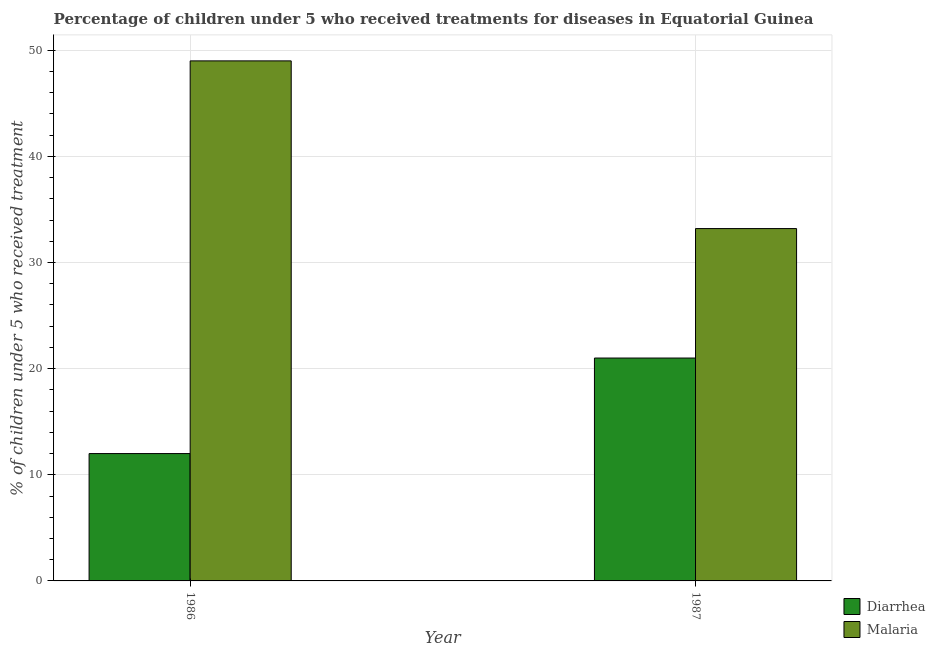How many different coloured bars are there?
Give a very brief answer. 2. How many groups of bars are there?
Ensure brevity in your answer.  2. How many bars are there on the 1st tick from the left?
Offer a terse response. 2. How many bars are there on the 1st tick from the right?
Your answer should be compact. 2. In how many cases, is the number of bars for a given year not equal to the number of legend labels?
Make the answer very short. 0. What is the percentage of children who received treatment for diarrhoea in 1986?
Your answer should be compact. 12. Across all years, what is the maximum percentage of children who received treatment for diarrhoea?
Provide a succinct answer. 21. Across all years, what is the minimum percentage of children who received treatment for diarrhoea?
Your answer should be compact. 12. In which year was the percentage of children who received treatment for diarrhoea maximum?
Make the answer very short. 1987. In which year was the percentage of children who received treatment for diarrhoea minimum?
Offer a very short reply. 1986. What is the total percentage of children who received treatment for malaria in the graph?
Your answer should be compact. 82.2. What is the difference between the percentage of children who received treatment for diarrhoea in 1986 and that in 1987?
Your response must be concise. -9. What is the difference between the percentage of children who received treatment for malaria in 1986 and the percentage of children who received treatment for diarrhoea in 1987?
Make the answer very short. 15.8. What is the average percentage of children who received treatment for diarrhoea per year?
Keep it short and to the point. 16.5. What is the ratio of the percentage of children who received treatment for diarrhoea in 1986 to that in 1987?
Offer a terse response. 0.57. What does the 2nd bar from the left in 1986 represents?
Offer a very short reply. Malaria. What does the 2nd bar from the right in 1986 represents?
Offer a terse response. Diarrhea. How many bars are there?
Your answer should be very brief. 4. Are all the bars in the graph horizontal?
Ensure brevity in your answer.  No. How many years are there in the graph?
Make the answer very short. 2. Are the values on the major ticks of Y-axis written in scientific E-notation?
Ensure brevity in your answer.  No. Does the graph contain grids?
Make the answer very short. Yes. How many legend labels are there?
Your answer should be very brief. 2. What is the title of the graph?
Offer a terse response. Percentage of children under 5 who received treatments for diseases in Equatorial Guinea. Does "Exports of goods" appear as one of the legend labels in the graph?
Your answer should be very brief. No. What is the label or title of the Y-axis?
Your response must be concise. % of children under 5 who received treatment. What is the % of children under 5 who received treatment of Malaria in 1986?
Your response must be concise. 49. What is the % of children under 5 who received treatment of Diarrhea in 1987?
Ensure brevity in your answer.  21. What is the % of children under 5 who received treatment of Malaria in 1987?
Give a very brief answer. 33.2. Across all years, what is the maximum % of children under 5 who received treatment in Diarrhea?
Provide a short and direct response. 21. Across all years, what is the maximum % of children under 5 who received treatment in Malaria?
Offer a terse response. 49. Across all years, what is the minimum % of children under 5 who received treatment in Diarrhea?
Keep it short and to the point. 12. Across all years, what is the minimum % of children under 5 who received treatment of Malaria?
Ensure brevity in your answer.  33.2. What is the total % of children under 5 who received treatment of Diarrhea in the graph?
Your response must be concise. 33. What is the total % of children under 5 who received treatment of Malaria in the graph?
Your answer should be compact. 82.2. What is the difference between the % of children under 5 who received treatment of Diarrhea in 1986 and the % of children under 5 who received treatment of Malaria in 1987?
Make the answer very short. -21.2. What is the average % of children under 5 who received treatment in Diarrhea per year?
Provide a succinct answer. 16.5. What is the average % of children under 5 who received treatment in Malaria per year?
Your answer should be very brief. 41.1. In the year 1986, what is the difference between the % of children under 5 who received treatment in Diarrhea and % of children under 5 who received treatment in Malaria?
Provide a short and direct response. -37. In the year 1987, what is the difference between the % of children under 5 who received treatment in Diarrhea and % of children under 5 who received treatment in Malaria?
Make the answer very short. -12.2. What is the ratio of the % of children under 5 who received treatment of Diarrhea in 1986 to that in 1987?
Ensure brevity in your answer.  0.57. What is the ratio of the % of children under 5 who received treatment in Malaria in 1986 to that in 1987?
Offer a terse response. 1.48. What is the difference between the highest and the lowest % of children under 5 who received treatment of Malaria?
Give a very brief answer. 15.8. 